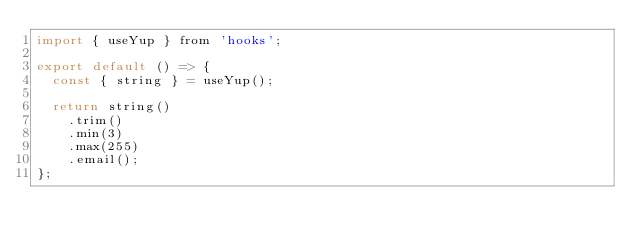Convert code to text. <code><loc_0><loc_0><loc_500><loc_500><_JavaScript_>import { useYup } from 'hooks';

export default () => {
  const { string } = useYup();

  return string()
    .trim()
    .min(3)
    .max(255)
    .email();
};
</code> 